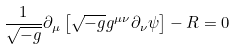Convert formula to latex. <formula><loc_0><loc_0><loc_500><loc_500>\frac { 1 } { \sqrt { - g } } \partial _ { \mu } \left [ \sqrt { - g } g ^ { \mu \nu } \partial _ { \nu } \psi \right ] - R = 0</formula> 